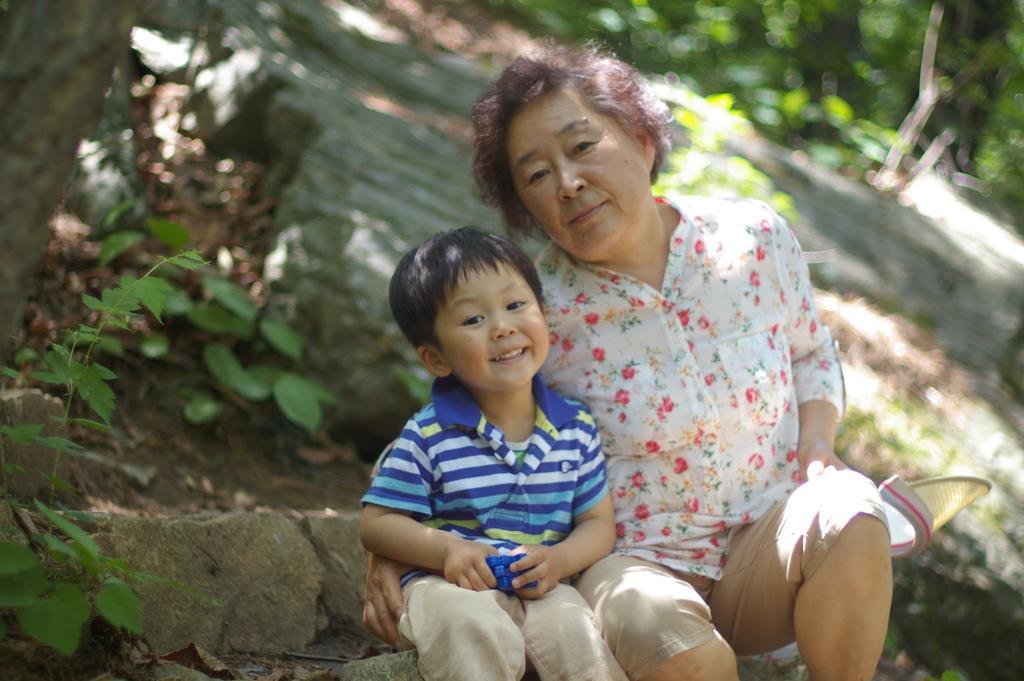Could you give a brief overview of what you see in this image? In this picture we can see an old woman wearing white and red flower shirt, sitting with the small boy, smiling and giving a pose. Behind there is a tree trunk, rocks and some trees. 